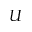<formula> <loc_0><loc_0><loc_500><loc_500>U</formula> 